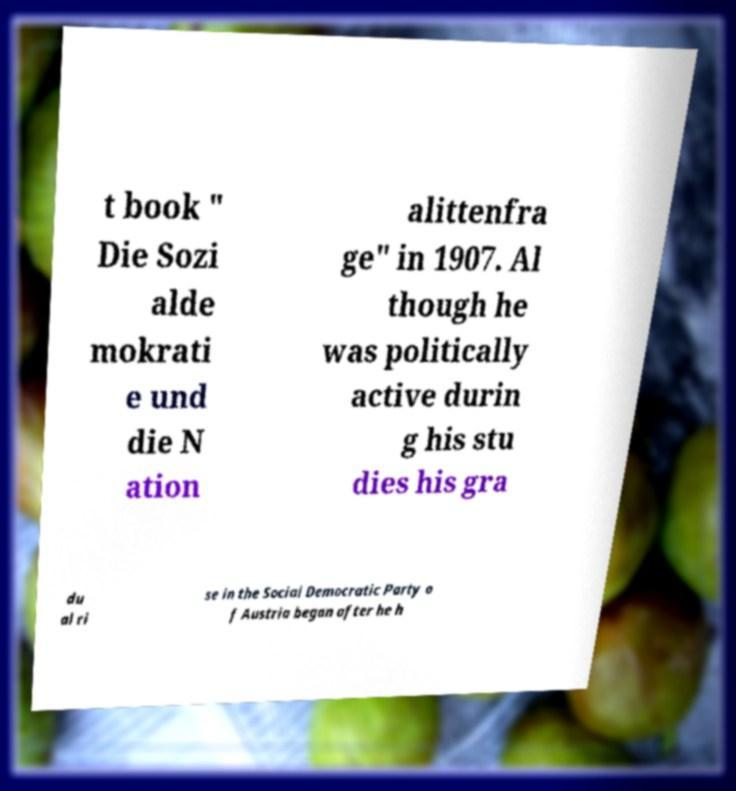Can you read and provide the text displayed in the image?This photo seems to have some interesting text. Can you extract and type it out for me? t book " Die Sozi alde mokrati e und die N ation alittenfra ge" in 1907. Al though he was politically active durin g his stu dies his gra du al ri se in the Social Democratic Party o f Austria began after he h 